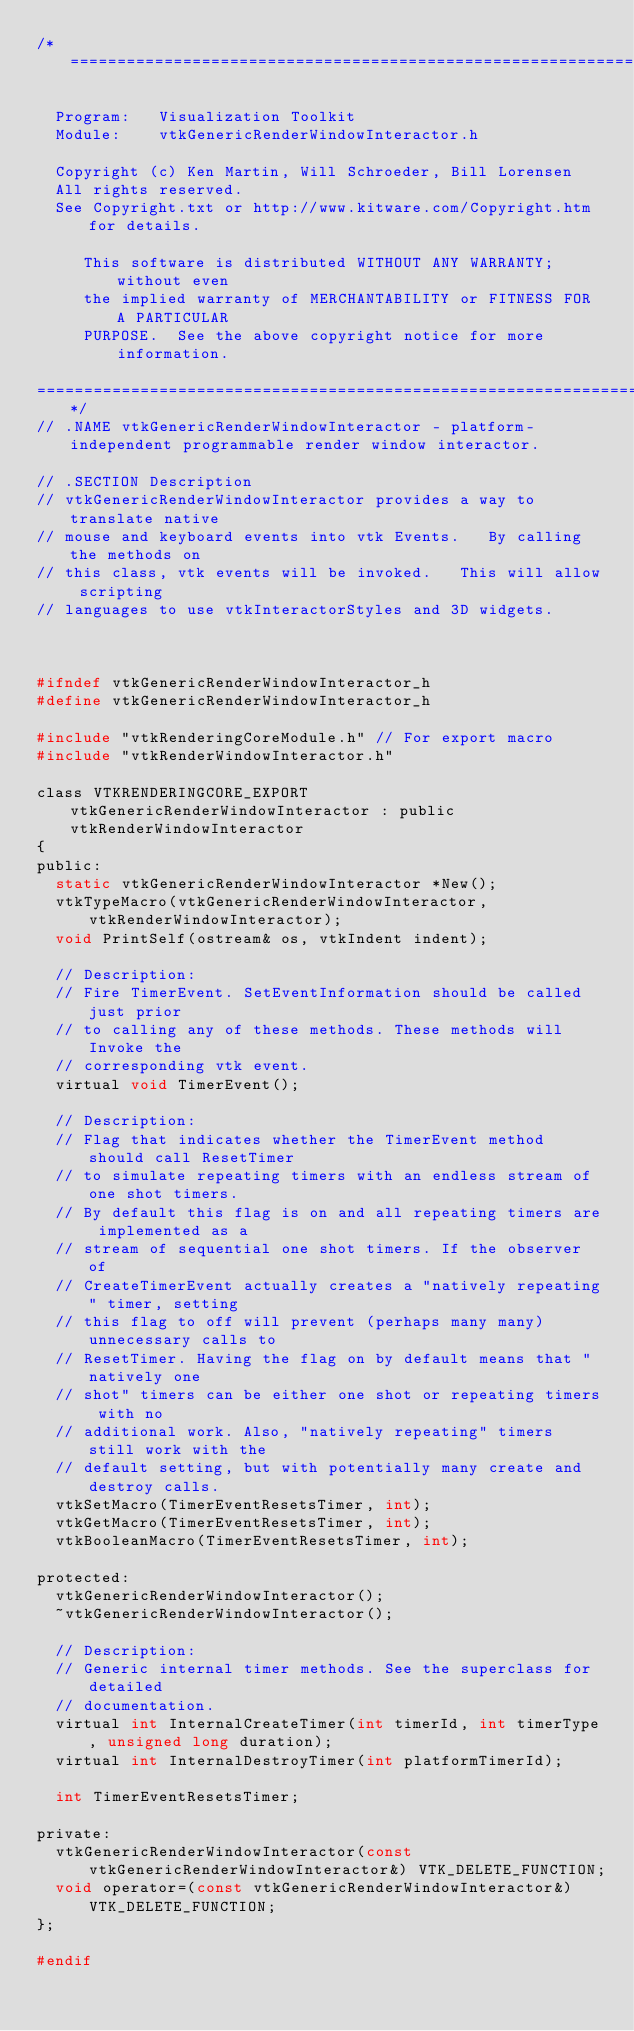<code> <loc_0><loc_0><loc_500><loc_500><_C_>/*=========================================================================

  Program:   Visualization Toolkit
  Module:    vtkGenericRenderWindowInteractor.h

  Copyright (c) Ken Martin, Will Schroeder, Bill Lorensen
  All rights reserved.
  See Copyright.txt or http://www.kitware.com/Copyright.htm for details.

     This software is distributed WITHOUT ANY WARRANTY; without even
     the implied warranty of MERCHANTABILITY or FITNESS FOR A PARTICULAR
     PURPOSE.  See the above copyright notice for more information.

=========================================================================*/
// .NAME vtkGenericRenderWindowInteractor - platform-independent programmable render window interactor.

// .SECTION Description
// vtkGenericRenderWindowInteractor provides a way to translate native
// mouse and keyboard events into vtk Events.   By calling the methods on
// this class, vtk events will be invoked.   This will allow scripting
// languages to use vtkInteractorStyles and 3D widgets.



#ifndef vtkGenericRenderWindowInteractor_h
#define vtkGenericRenderWindowInteractor_h

#include "vtkRenderingCoreModule.h" // For export macro
#include "vtkRenderWindowInteractor.h"

class VTKRENDERINGCORE_EXPORT vtkGenericRenderWindowInteractor : public vtkRenderWindowInteractor
{
public:
  static vtkGenericRenderWindowInteractor *New();
  vtkTypeMacro(vtkGenericRenderWindowInteractor,vtkRenderWindowInteractor);
  void PrintSelf(ostream& os, vtkIndent indent);

  // Description:
  // Fire TimerEvent. SetEventInformation should be called just prior
  // to calling any of these methods. These methods will Invoke the
  // corresponding vtk event.
  virtual void TimerEvent();

  // Description:
  // Flag that indicates whether the TimerEvent method should call ResetTimer
  // to simulate repeating timers with an endless stream of one shot timers.
  // By default this flag is on and all repeating timers are implemented as a
  // stream of sequential one shot timers. If the observer of
  // CreateTimerEvent actually creates a "natively repeating" timer, setting
  // this flag to off will prevent (perhaps many many) unnecessary calls to
  // ResetTimer. Having the flag on by default means that "natively one
  // shot" timers can be either one shot or repeating timers with no
  // additional work. Also, "natively repeating" timers still work with the
  // default setting, but with potentially many create and destroy calls.
  vtkSetMacro(TimerEventResetsTimer, int);
  vtkGetMacro(TimerEventResetsTimer, int);
  vtkBooleanMacro(TimerEventResetsTimer, int);

protected:
  vtkGenericRenderWindowInteractor();
  ~vtkGenericRenderWindowInteractor();

  // Description:
  // Generic internal timer methods. See the superclass for detailed
  // documentation.
  virtual int InternalCreateTimer(int timerId, int timerType, unsigned long duration);
  virtual int InternalDestroyTimer(int platformTimerId);

  int TimerEventResetsTimer;

private:
  vtkGenericRenderWindowInteractor(const vtkGenericRenderWindowInteractor&) VTK_DELETE_FUNCTION;
  void operator=(const vtkGenericRenderWindowInteractor&) VTK_DELETE_FUNCTION;
};

#endif
</code> 